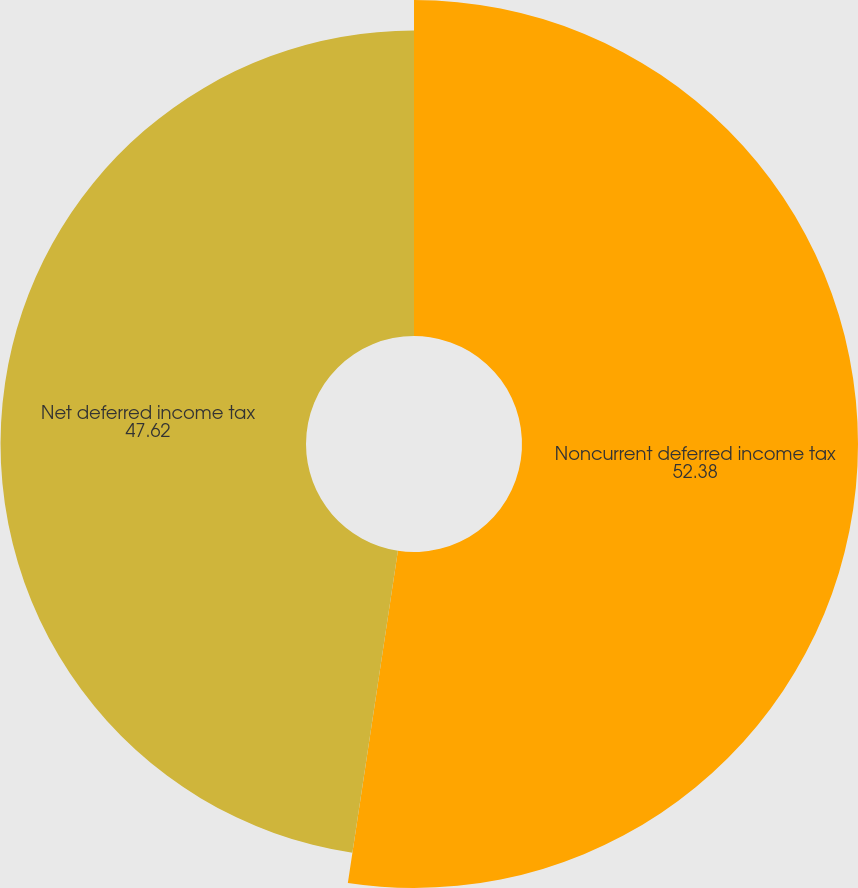Convert chart. <chart><loc_0><loc_0><loc_500><loc_500><pie_chart><fcel>Noncurrent deferred income tax<fcel>Net deferred income tax<nl><fcel>52.38%<fcel>47.62%<nl></chart> 